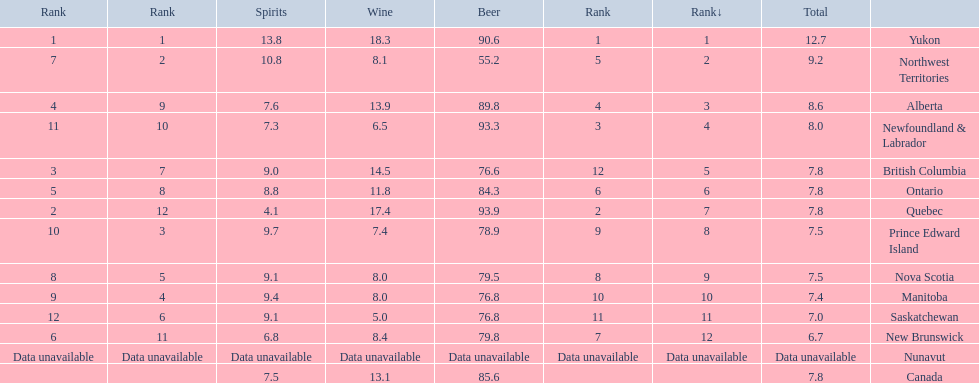What are all the canadian regions? Yukon, Northwest Territories, Alberta, Newfoundland & Labrador, British Columbia, Ontario, Quebec, Prince Edward Island, Nova Scotia, Manitoba, Saskatchewan, New Brunswick, Nunavut, Canada. What was the spirits consumption? 13.8, 10.8, 7.6, 7.3, 9.0, 8.8, 4.1, 9.7, 9.1, 9.4, 9.1, 6.8, Data unavailable, 7.5. What was quebec's spirit consumption? 4.1. 